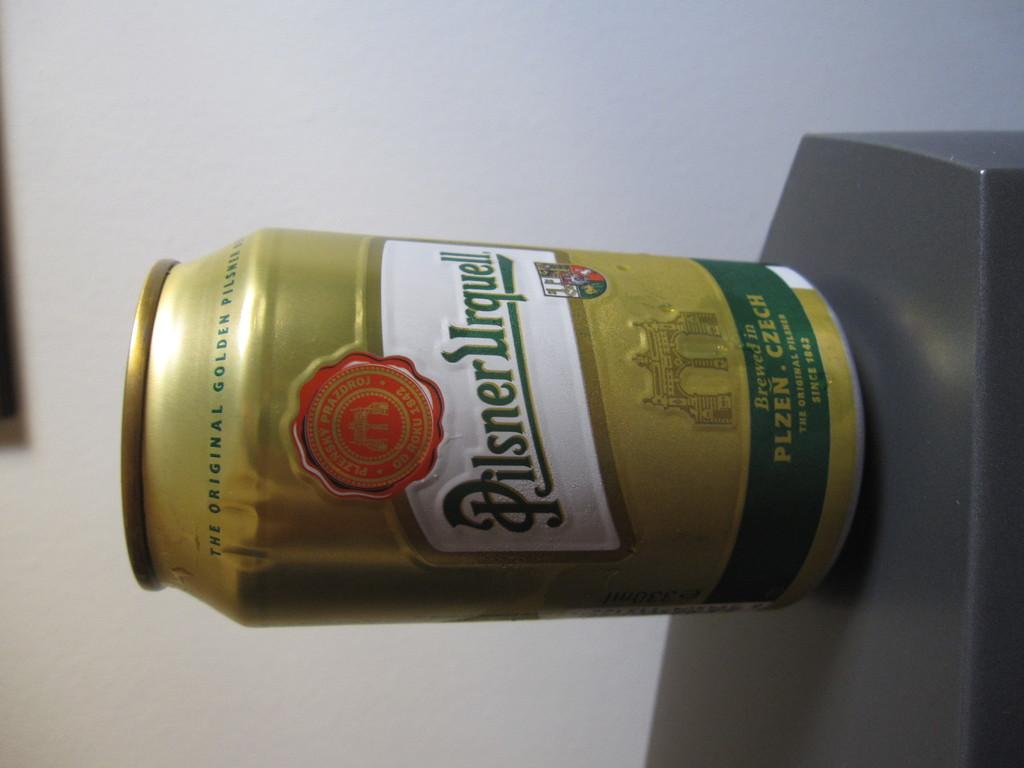<image>
Summarize the visual content of the image. A can of Pilsner Urquell has a red seal on the label. 